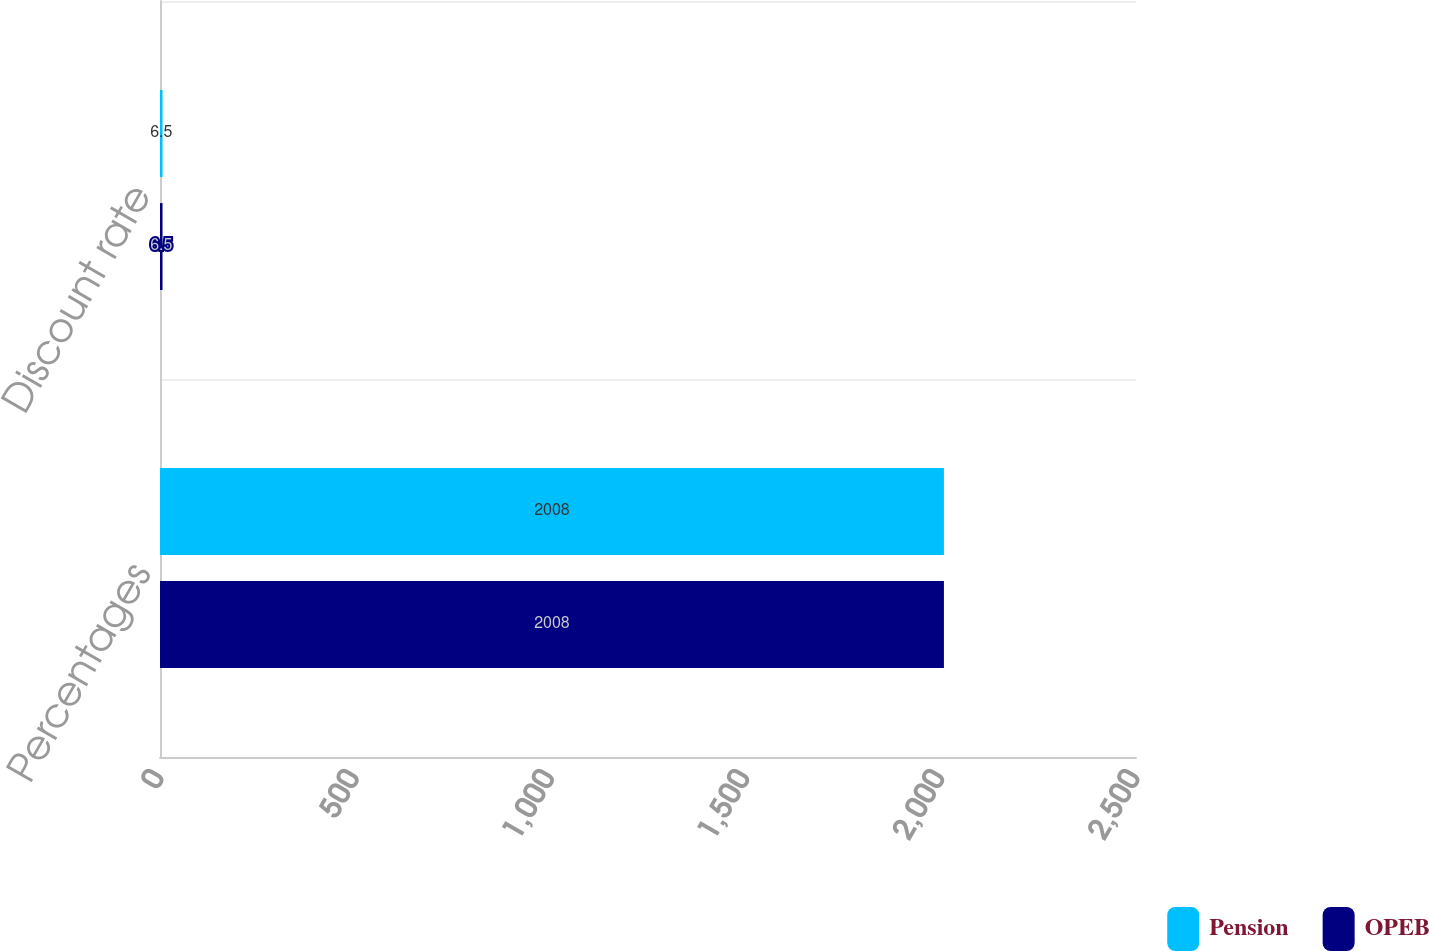Convert chart. <chart><loc_0><loc_0><loc_500><loc_500><stacked_bar_chart><ecel><fcel>Percentages<fcel>Discount rate<nl><fcel>Pension<fcel>2008<fcel>6.5<nl><fcel>OPEB<fcel>2008<fcel>6.5<nl></chart> 